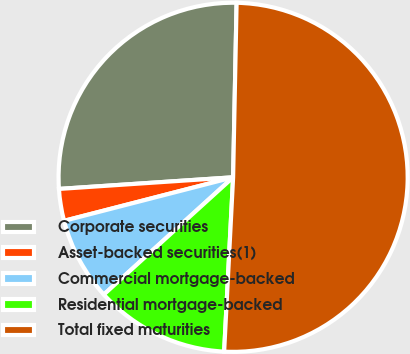Convert chart to OTSL. <chart><loc_0><loc_0><loc_500><loc_500><pie_chart><fcel>Corporate securities<fcel>Asset-backed securities(1)<fcel>Commercial mortgage-backed<fcel>Residential mortgage-backed<fcel>Total fixed maturities<nl><fcel>26.38%<fcel>2.95%<fcel>7.71%<fcel>12.46%<fcel>50.5%<nl></chart> 